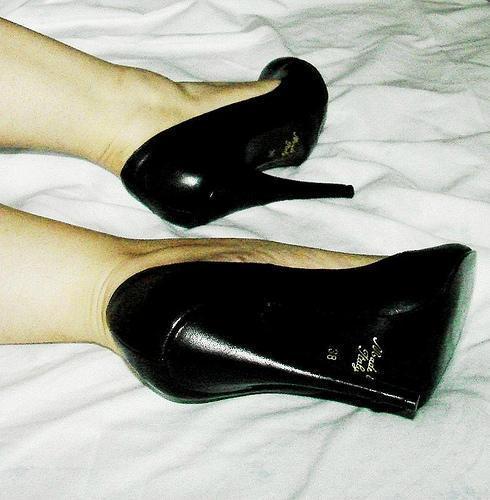How many of the train's visible cars have yellow on them>?
Give a very brief answer. 0. 